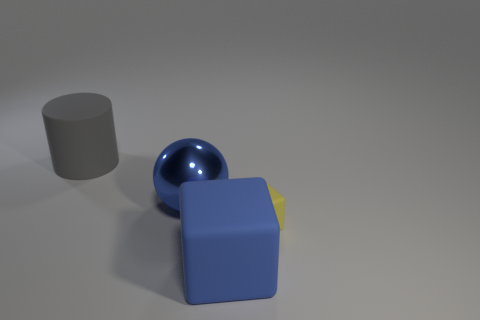There is a cube that is the same color as the metallic object; what is it made of?
Make the answer very short. Rubber. What color is the other big rubber thing that is the same shape as the yellow object?
Your response must be concise. Blue. What is the material of the big cylinder?
Your answer should be very brief. Rubber. Are there any other things that are the same size as the yellow rubber object?
Provide a succinct answer. No. What size is the blue object that is the same shape as the tiny yellow matte object?
Provide a succinct answer. Large. Do the large rubber cube and the large sphere have the same color?
Provide a short and direct response. Yes. What number of other objects are the same shape as the tiny thing?
Make the answer very short. 1. Is the number of rubber objects to the left of the yellow rubber cube greater than the number of yellow rubber objects that are left of the gray matte cylinder?
Your response must be concise. Yes. Does the matte object that is on the left side of the large metal ball have the same size as the thing that is to the right of the blue rubber object?
Your answer should be very brief. No. What is the shape of the blue metallic thing?
Give a very brief answer. Sphere. 